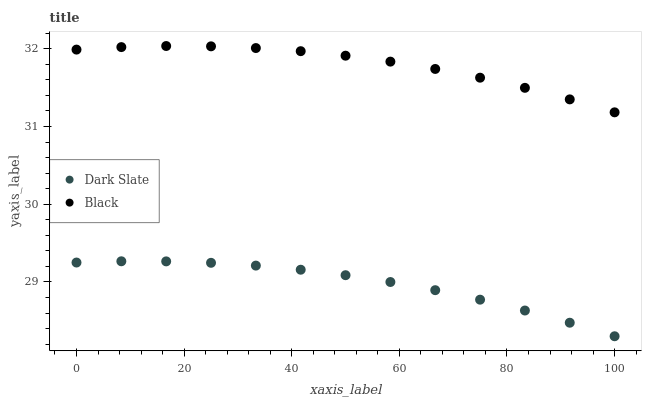Does Dark Slate have the minimum area under the curve?
Answer yes or no. Yes. Does Black have the maximum area under the curve?
Answer yes or no. Yes. Does Black have the minimum area under the curve?
Answer yes or no. No. Is Dark Slate the smoothest?
Answer yes or no. Yes. Is Black the roughest?
Answer yes or no. Yes. Is Black the smoothest?
Answer yes or no. No. Does Dark Slate have the lowest value?
Answer yes or no. Yes. Does Black have the lowest value?
Answer yes or no. No. Does Black have the highest value?
Answer yes or no. Yes. Is Dark Slate less than Black?
Answer yes or no. Yes. Is Black greater than Dark Slate?
Answer yes or no. Yes. Does Dark Slate intersect Black?
Answer yes or no. No. 